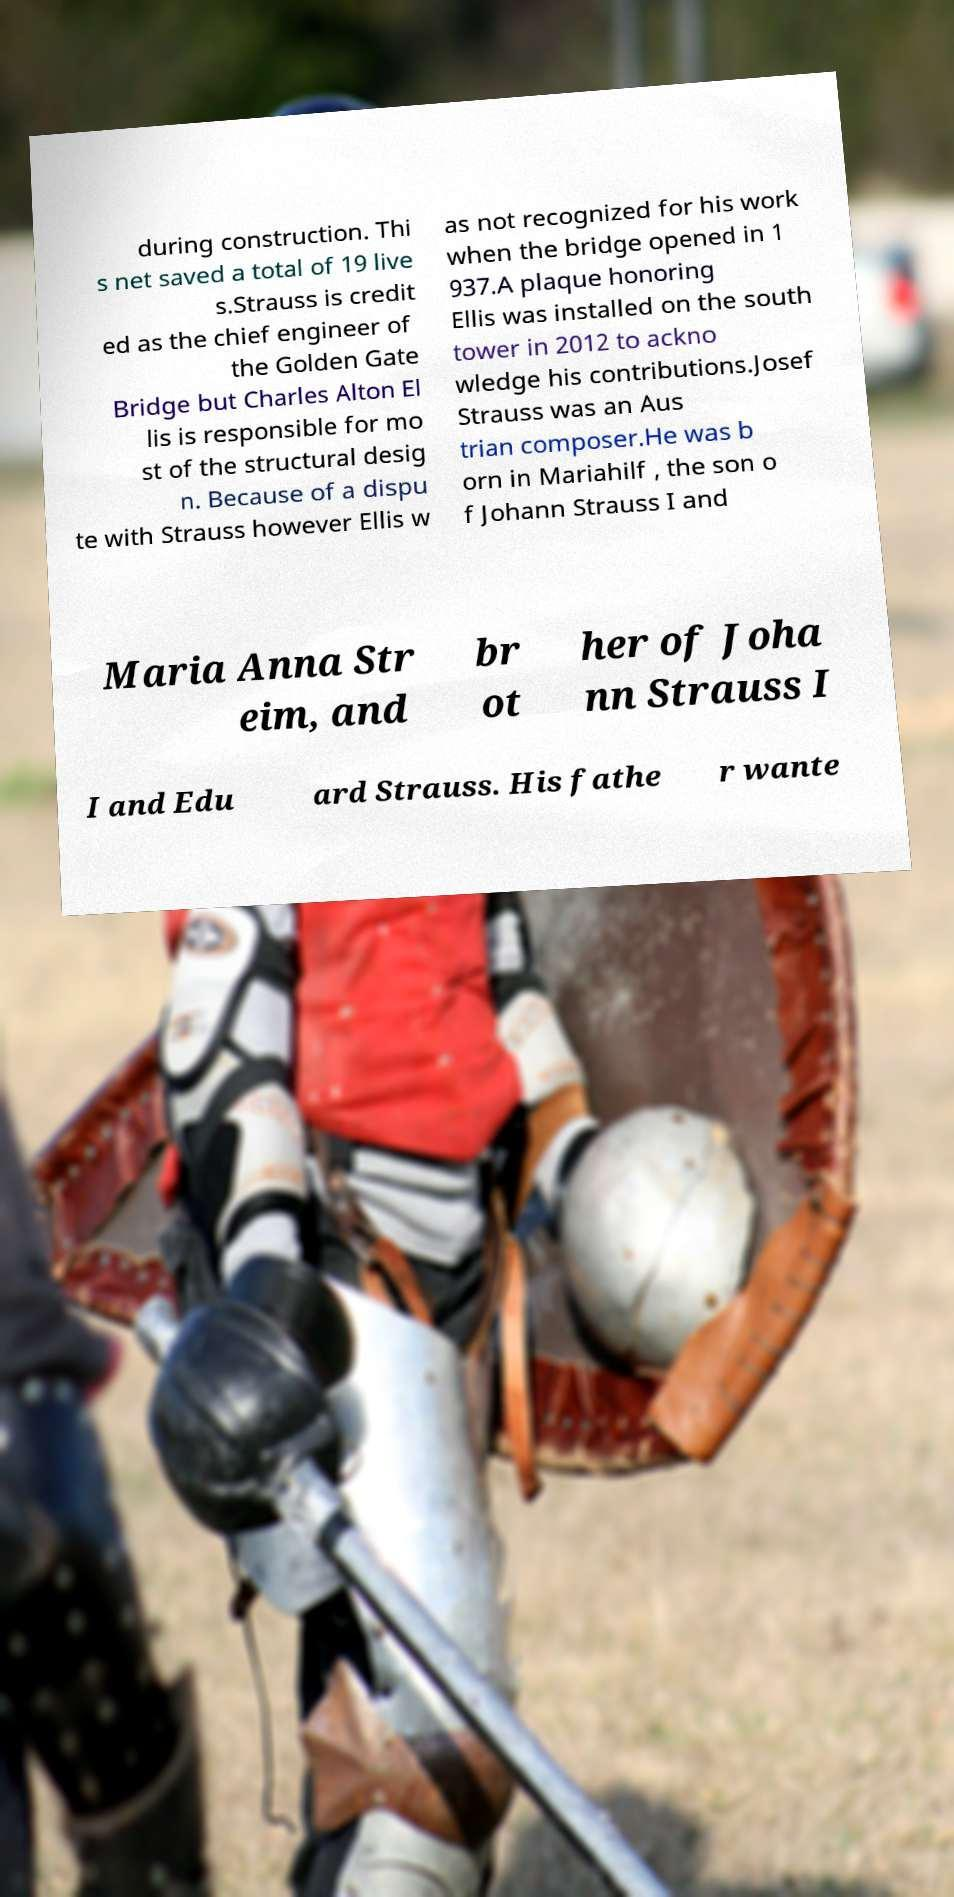Please read and relay the text visible in this image. What does it say? during construction. Thi s net saved a total of 19 live s.Strauss is credit ed as the chief engineer of the Golden Gate Bridge but Charles Alton El lis is responsible for mo st of the structural desig n. Because of a dispu te with Strauss however Ellis w as not recognized for his work when the bridge opened in 1 937.A plaque honoring Ellis was installed on the south tower in 2012 to ackno wledge his contributions.Josef Strauss was an Aus trian composer.He was b orn in Mariahilf , the son o f Johann Strauss I and Maria Anna Str eim, and br ot her of Joha nn Strauss I I and Edu ard Strauss. His fathe r wante 